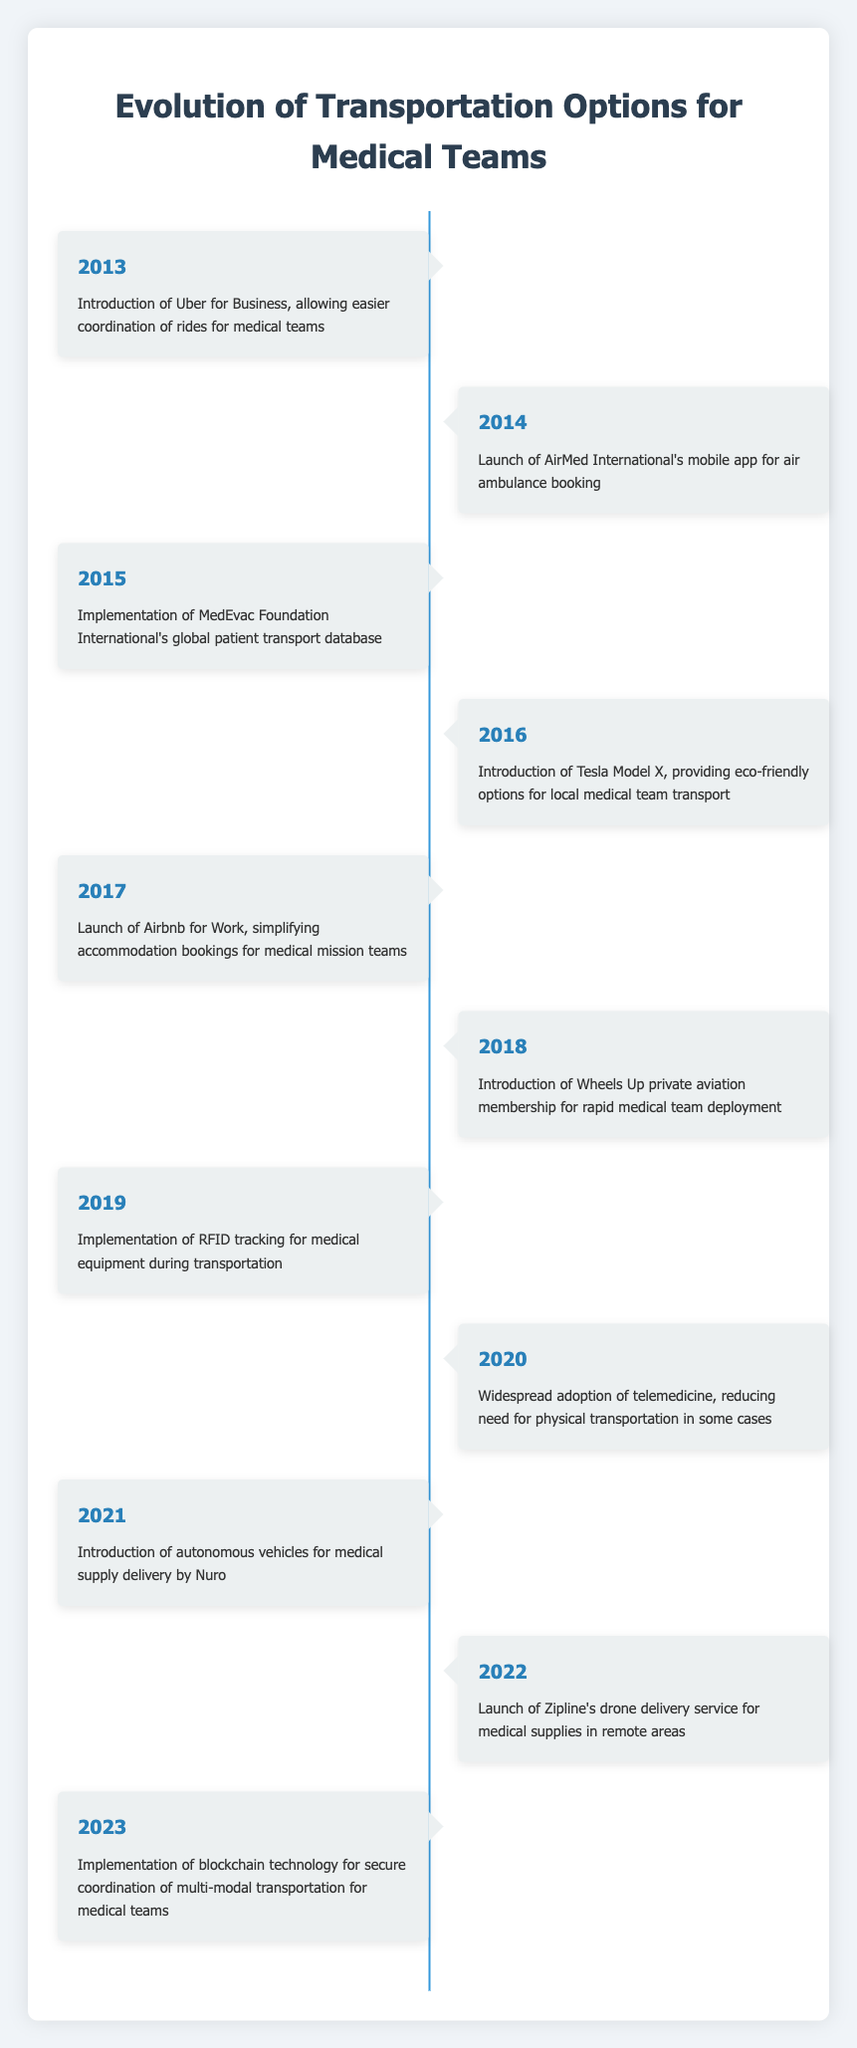What transportation technology was introduced in 2013? The timeline specifies that in 2013, the "Introduction of Uber for Business" was the event that occurred. This was aimed at allowing easier coordination of rides for medical teams.
Answer: Uber for Business In what year did the launch of a mobile app for air ambulance booking happen? According to the timeline, the launch of AirMed International's mobile app for air ambulance booking took place in 2014.
Answer: 2014 Which event signifies the start of eco-friendly transportation options for medical teams? The introduction of the Tesla Model X in 2016 significantly highlights the start of eco-friendly transportation options for local medical team transport, as it is designed to be environmentally friendly.
Answer: Introduction of Tesla Model X What percentage of the timeline events relates to advancements in drone technology? Out of the 11 timeline events, 2 events specifically relate to drone technology: the launch of Zipline’s drone delivery service in 2022 and the use of autonomous vehicles by Nuro in 2021. Thus, the percentage calculation is (2/11) * 100, which is approximately 18.2%.
Answer: 18.2% True or False: The adoption of telemedicine in 2020 increased the need for physical transportation. The timeline states that in 2020, the widespread adoption of telemedicine actually "reducing need for physical transportation in some cases," indicating that it did not increase the need for transportation. Therefore, the answer is false.
Answer: False What was the significance of the RFID tracking implementation in 2019 for medical teams? The event in 2019 pertains to the "Implementation of RFID tracking for medical equipment during transportation." This technology enhances the tracking and safety of medical equipment, which is essential for efficient transportation of goods by medical teams.
Answer: Enhance tracking and safety Which two events in the timeline specifically address improvements in accommodation for medical mission teams? The two events related to improvement in accommodations for medical mission teams are the launch of Airbnb for Work in 2017 and the simplified accommodation bookings. These two events together highlight advancements in accommodation options for medical teams.
Answer: Airbnb for Work; simplified accommodation bookings How many years were there between the introduction of telemedicine and the implementation of blockchain technology? Telemedicine was widely adopted in 2020 and blockchain technology was implemented in 2023. The years between 2020 and 2023 is 3 years, calculated as 2023 - 2020 = 3.
Answer: 3 years 